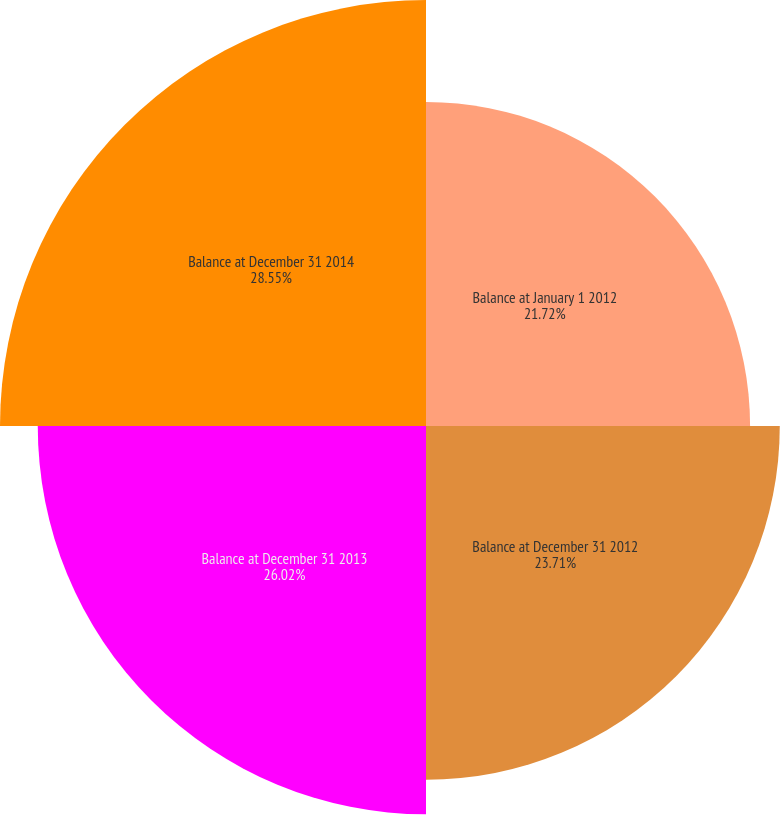<chart> <loc_0><loc_0><loc_500><loc_500><pie_chart><fcel>Balance at January 1 2012<fcel>Balance at December 31 2012<fcel>Balance at December 31 2013<fcel>Balance at December 31 2014<nl><fcel>21.72%<fcel>23.71%<fcel>26.02%<fcel>28.55%<nl></chart> 